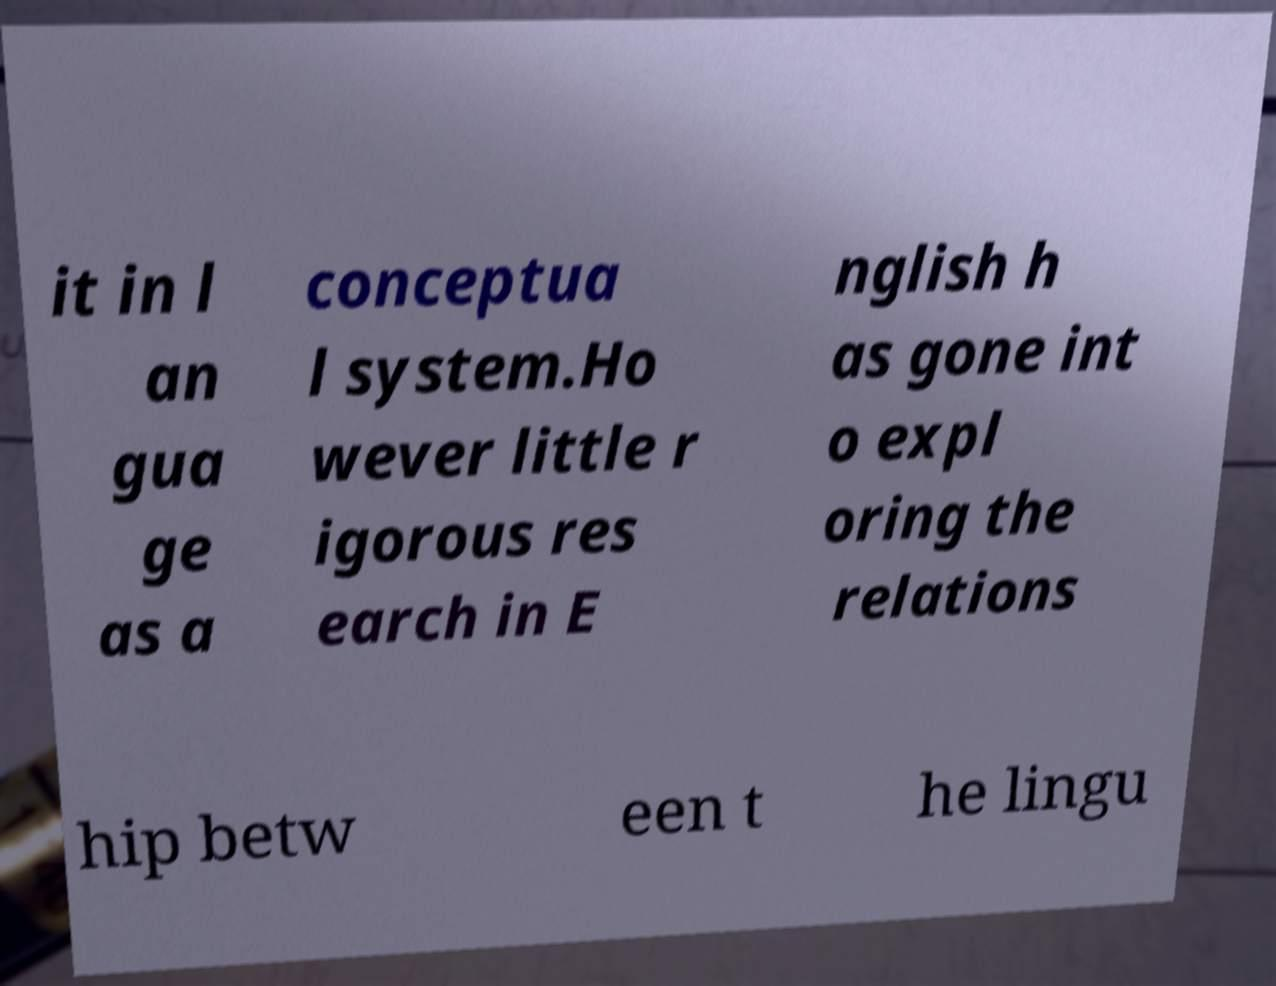Can you read and provide the text displayed in the image?This photo seems to have some interesting text. Can you extract and type it out for me? it in l an gua ge as a conceptua l system.Ho wever little r igorous res earch in E nglish h as gone int o expl oring the relations hip betw een t he lingu 